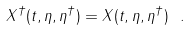<formula> <loc_0><loc_0><loc_500><loc_500>X ^ { \dagger } ( t , \eta , \eta ^ { \dagger } ) = X ( t , \eta , \eta ^ { \dagger } ) \ .</formula> 